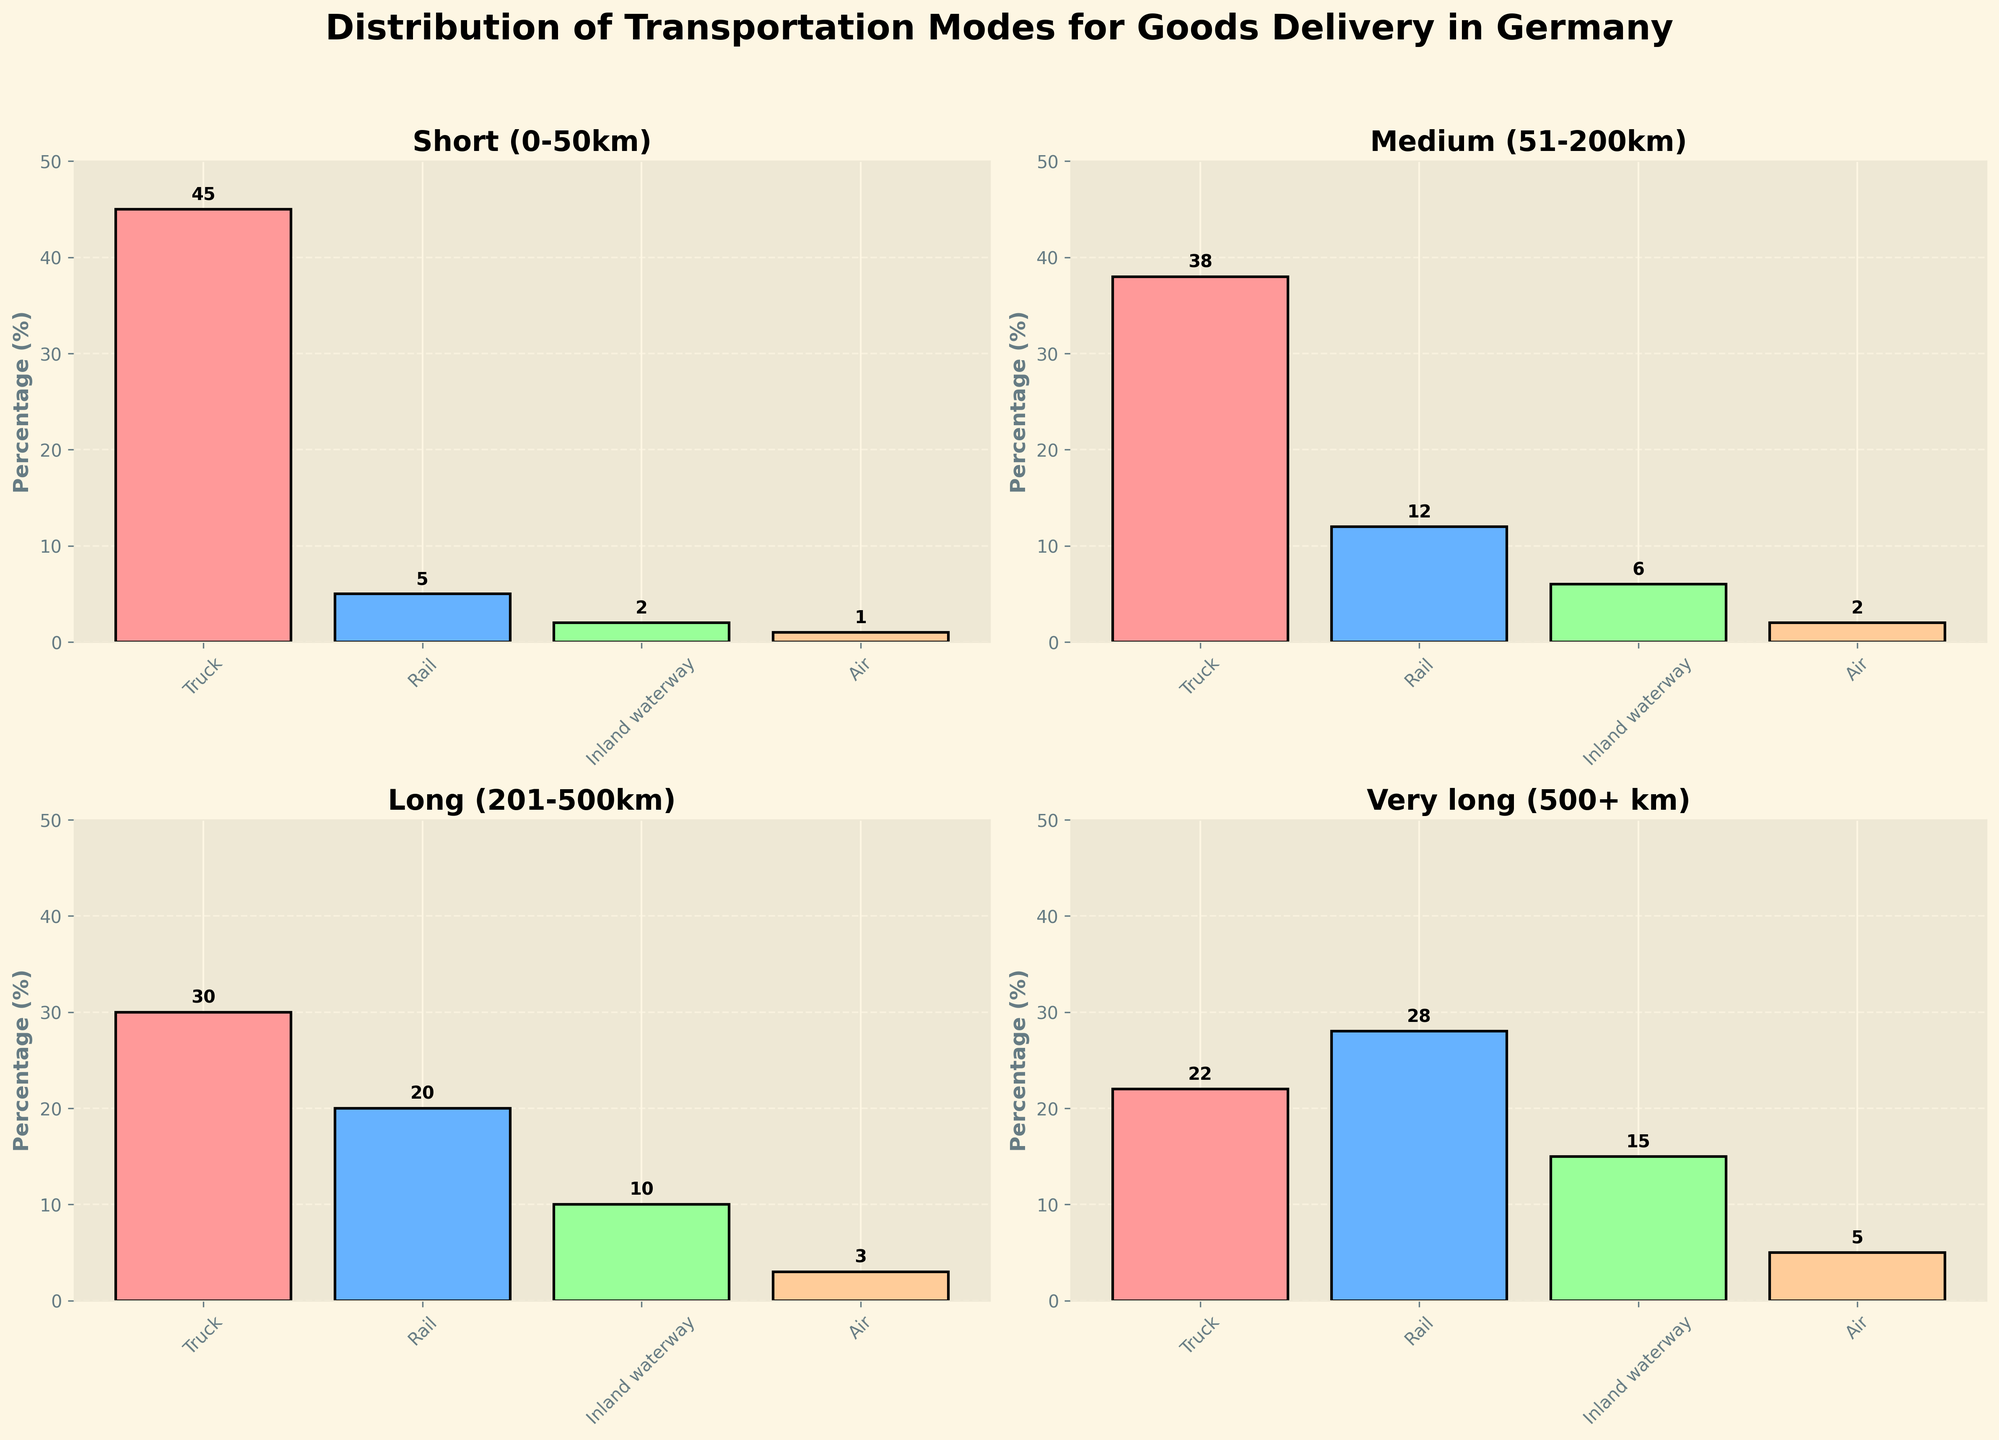How many transportation modes are used for short-distance delivery (0-50km)? The 'Short (0-50km)' subplot in the figure shows four bars, each representing a different transportation mode. So, we count the number of bars in this subplot.
Answer: 4 Which transportation mode has the highest percentage for medium-distance delivery (51-200km)? In the 'Medium (51-200km)' subplot, the bar representing trucks has the highest height, indicating the highest percentage.
Answer: Truck What is the total percentage of all transportation modes for very long distances (500+ km)? We add up the percentages of all transportation modes in the 'Very long (500+ km)' subplot: 22% (Truck) + 28% (Rail) + 15% (Inland waterway) + 5% (Air) = 70%.
Answer: 70% Between trucks and rail, which transportation mode is more dominant over long distances (201-500km)? In the 'Long (201-500km)' subplot, the truck bar is higher than the rail bar (30% vs. 20%), indicating that trucks are more dominant.
Answer: Truck What is the difference in percentage between air transport in short-distance and medium-distance delivery? From the 'Short (0-50km)' and 'Medium (51-200km)' subplots, air transport is 1% and 2%, respectively. The difference is 2% - 1% = 1%.
Answer: 1% Which distance category relies most heavily on rail transport? We compare the heights of the rail bars across all distance categories. The 'Very long (500+ km)' subplot shows the highest rail usage at 28%.
Answer: Very long (500+ km) What are the visual indicators used to differentiate between different distance categories in the figure? The figure uses different subplots with distinct titles to represent each distance category and employs varying colors for the bars.
Answer: Subplots and colors Which distance category has the lowest usage of inland waterway transportation? We look at the heights of the inland waterway bars across all subplots. The 'Short (0-50km)' subplot has the lowest at 2%.
Answer: Short (0-50km) How does the percentage of truck transportation change as the distance category increases? Truck usage percentages by distance: Short (45%), Medium (38%), Long (30%), Very long (22%). There is a decreasing trend as the distance increases.
Answer: Decreases What is the combined percentage of air transport for all distance categories? Summing air transport percentages across all subplots: 1% (Short) + 2% (Medium) + 3% (Long) + 5% (Very long) = 11%.
Answer: 11% 